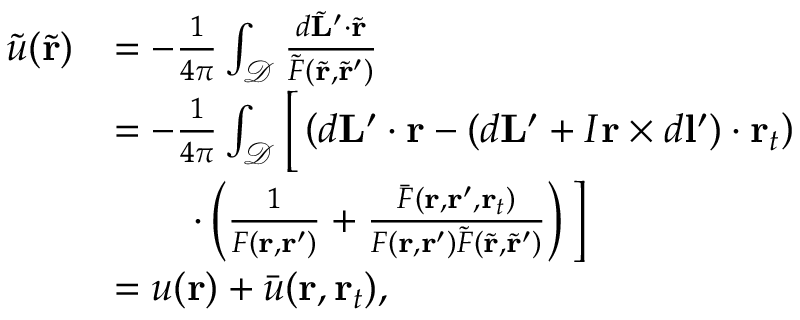Convert formula to latex. <formula><loc_0><loc_0><loc_500><loc_500>\begin{array} { r l } { \tilde { u } ( \tilde { r } ) } & { = - \frac { 1 } { 4 \pi } \int _ { \mathcal { D } } \frac { d \tilde { L } ^ { \prime } \cdot \tilde { r } } { \tilde { F } ( \tilde { r } , \tilde { r } ^ { \prime } ) } } \\ & { = - \frac { 1 } { 4 \pi } \int _ { \mathcal { D } } \left [ \left ( d L ^ { \prime } \cdot r - ( d L ^ { \prime } + I r \times d l ^ { \prime } ) \cdot r _ { t } \right ) } \\ & { \quad \cdot \left ( \frac { 1 } { F ( r , r ^ { \prime } ) } + \frac { \bar { F } ( r , r ^ { \prime } , r _ { t } ) } { F ( r , r ^ { \prime } ) \tilde { F } ( \tilde { r } , \tilde { r } ^ { \prime } ) } \right ) \right ] } \\ & { = u ( r ) + \bar { u } ( r , r _ { t } ) , } \end{array}</formula> 